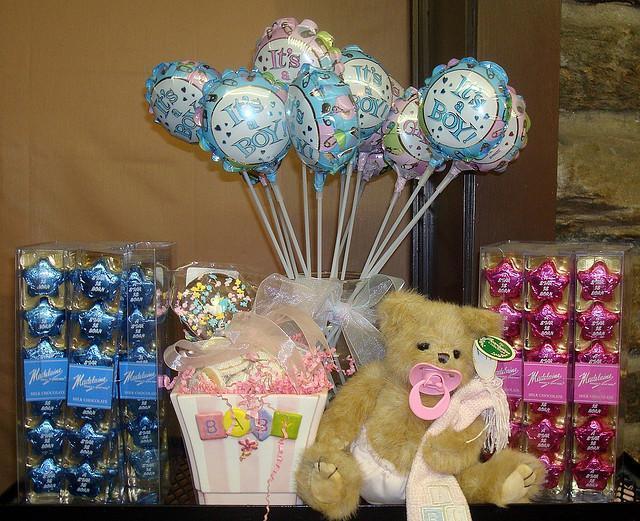How many stuffed animals are there?
Give a very brief answer. 1. How many teddy bears are in the photo?
Give a very brief answer. 1. How many people are wearing white shirts?
Give a very brief answer. 0. 